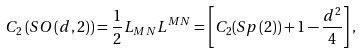<formula> <loc_0><loc_0><loc_500><loc_500>C _ { 2 } \left ( S O \left ( d , 2 \right ) \right ) = \frac { 1 } { 2 } L _ { M N } L ^ { M N } = \left [ C _ { 2 } ( S p \left ( 2 \right ) ) + 1 - \frac { d ^ { 2 } } 4 \right ] ,</formula> 